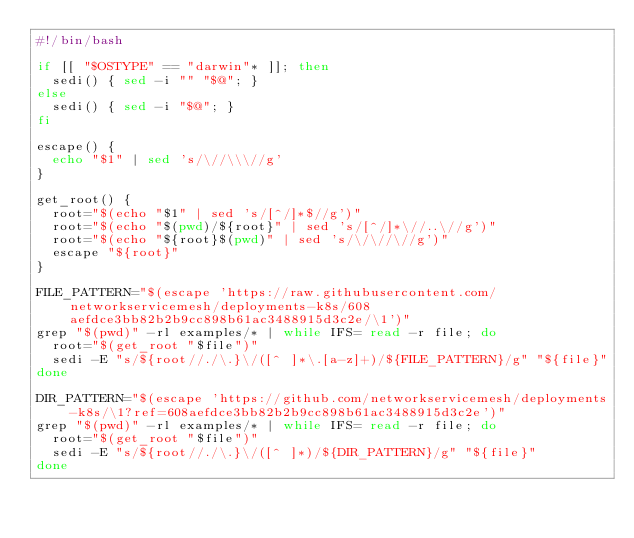Convert code to text. <code><loc_0><loc_0><loc_500><loc_500><_Bash_>#!/bin/bash

if [[ "$OSTYPE" == "darwin"* ]]; then
  sedi() { sed -i "" "$@"; }
else
  sedi() { sed -i "$@"; }
fi

escape() {
  echo "$1" | sed 's/\//\\\//g'
}

get_root() {
  root="$(echo "$1" | sed 's/[^/]*$//g')"
  root="$(echo "$(pwd)/${root}" | sed 's/[^/]*\//..\//g')"
  root="$(echo "${root}$(pwd)" | sed 's/\/\//\//g')"
  escape "${root}"
}

FILE_PATTERN="$(escape 'https://raw.githubusercontent.com/networkservicemesh/deployments-k8s/608aefdce3bb82b2b9cc898b61ac3488915d3c2e/\1')"
grep "$(pwd)" -rl examples/* | while IFS= read -r file; do
  root="$(get_root "$file")"
  sedi -E "s/${root//./\.}\/([^ ]*\.[a-z]+)/${FILE_PATTERN}/g" "${file}"
done

DIR_PATTERN="$(escape 'https://github.com/networkservicemesh/deployments-k8s/\1?ref=608aefdce3bb82b2b9cc898b61ac3488915d3c2e')"
grep "$(pwd)" -rl examples/* | while IFS= read -r file; do
  root="$(get_root "$file")"
  sedi -E "s/${root//./\.}\/([^ ]*)/${DIR_PATTERN}/g" "${file}"
done
</code> 